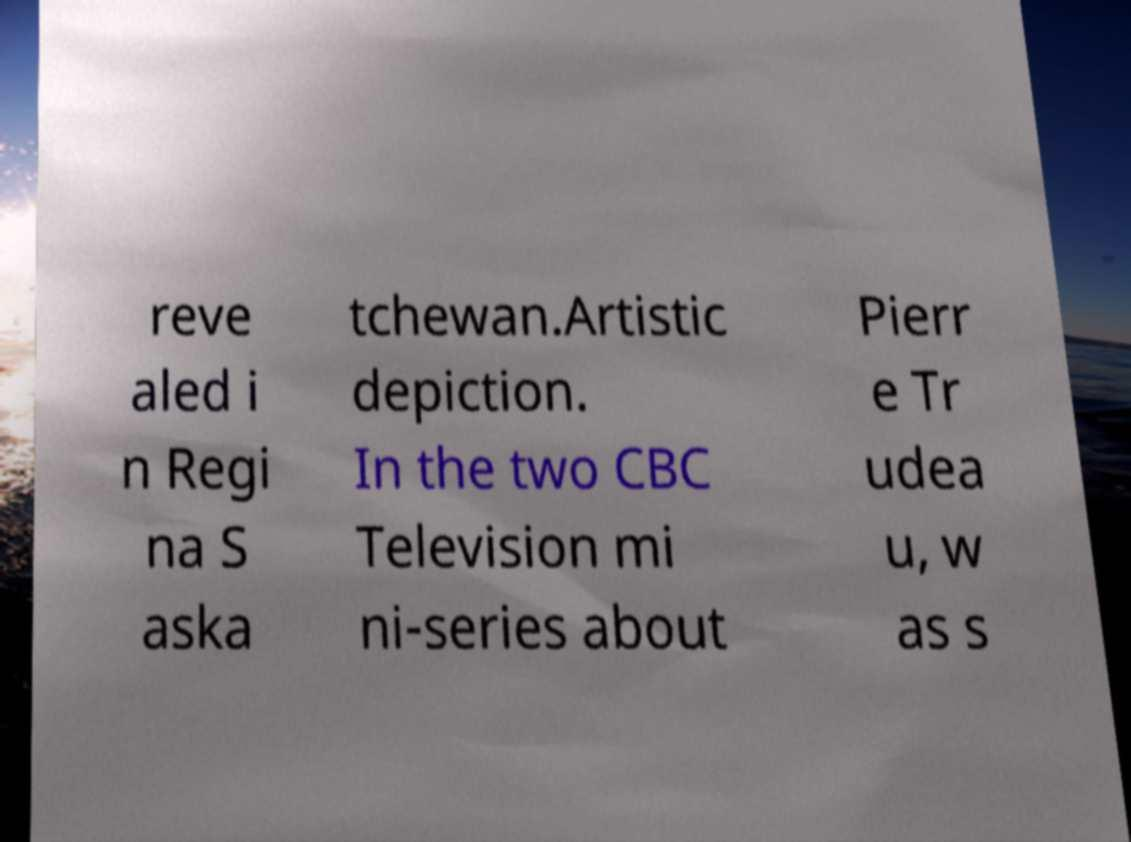I need the written content from this picture converted into text. Can you do that? reve aled i n Regi na S aska tchewan.Artistic depiction. In the two CBC Television mi ni-series about Pierr e Tr udea u, w as s 